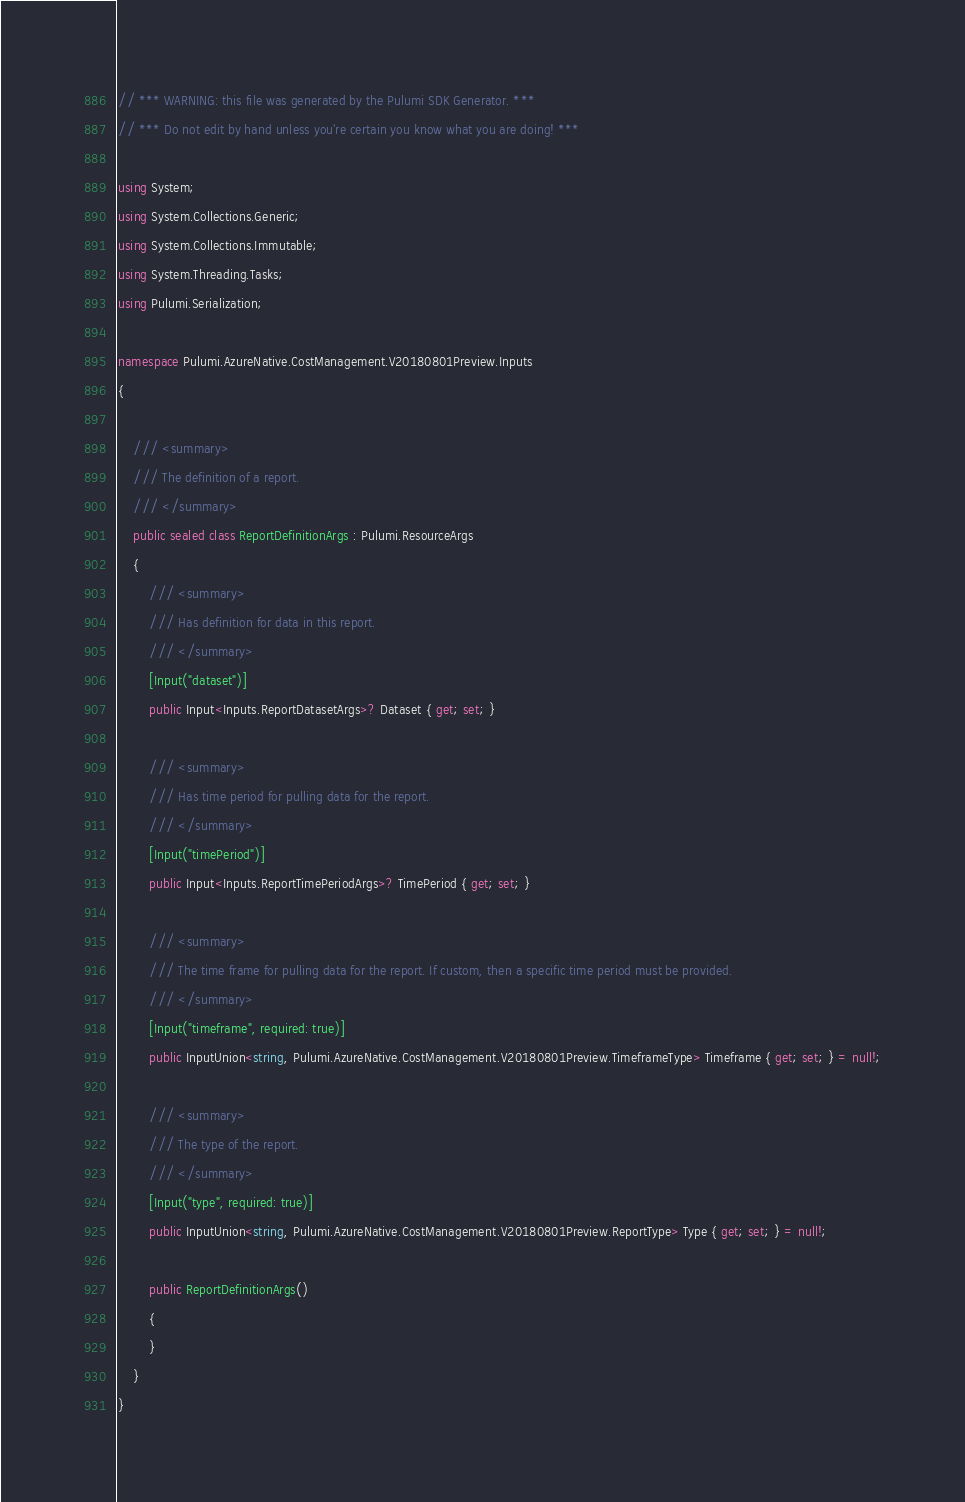<code> <loc_0><loc_0><loc_500><loc_500><_C#_>// *** WARNING: this file was generated by the Pulumi SDK Generator. ***
// *** Do not edit by hand unless you're certain you know what you are doing! ***

using System;
using System.Collections.Generic;
using System.Collections.Immutable;
using System.Threading.Tasks;
using Pulumi.Serialization;

namespace Pulumi.AzureNative.CostManagement.V20180801Preview.Inputs
{

    /// <summary>
    /// The definition of a report.
    /// </summary>
    public sealed class ReportDefinitionArgs : Pulumi.ResourceArgs
    {
        /// <summary>
        /// Has definition for data in this report.
        /// </summary>
        [Input("dataset")]
        public Input<Inputs.ReportDatasetArgs>? Dataset { get; set; }

        /// <summary>
        /// Has time period for pulling data for the report.
        /// </summary>
        [Input("timePeriod")]
        public Input<Inputs.ReportTimePeriodArgs>? TimePeriod { get; set; }

        /// <summary>
        /// The time frame for pulling data for the report. If custom, then a specific time period must be provided.
        /// </summary>
        [Input("timeframe", required: true)]
        public InputUnion<string, Pulumi.AzureNative.CostManagement.V20180801Preview.TimeframeType> Timeframe { get; set; } = null!;

        /// <summary>
        /// The type of the report.
        /// </summary>
        [Input("type", required: true)]
        public InputUnion<string, Pulumi.AzureNative.CostManagement.V20180801Preview.ReportType> Type { get; set; } = null!;

        public ReportDefinitionArgs()
        {
        }
    }
}
</code> 